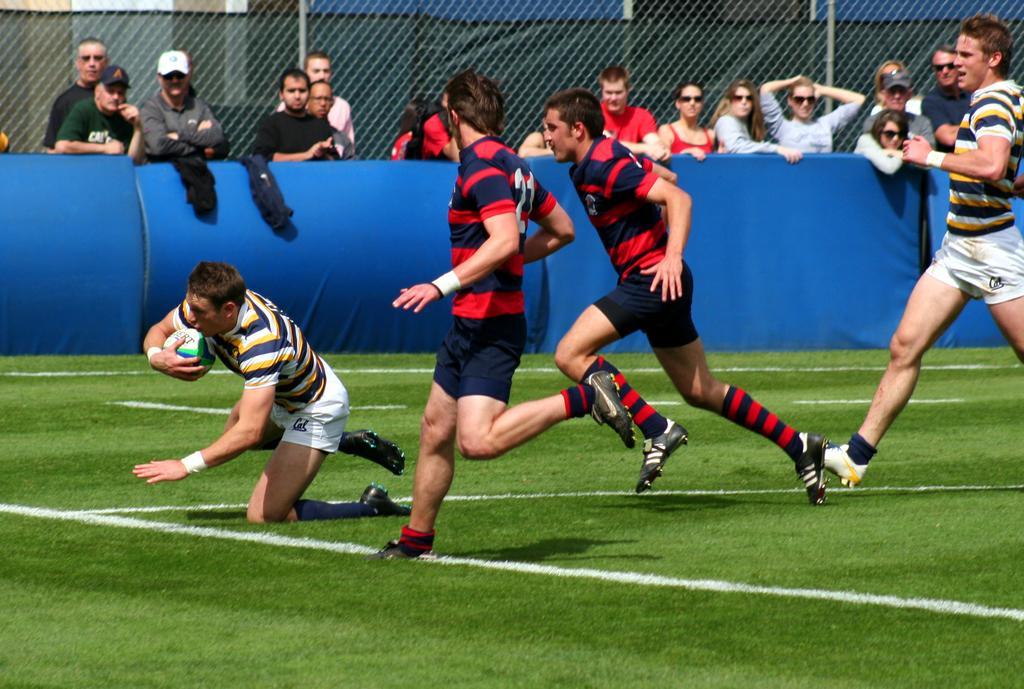Can you describe this image briefly? In this image I can see people playing rugby game. At the background there are some people standing and watching the game. I can see a man wearing white cap and goggles. I can see a man with yellow and blue striped T-Shirt with white shirt and running. Here is another man holding the rugby ball in his hand. I can see a woman standing and watching the rugby ball game. 